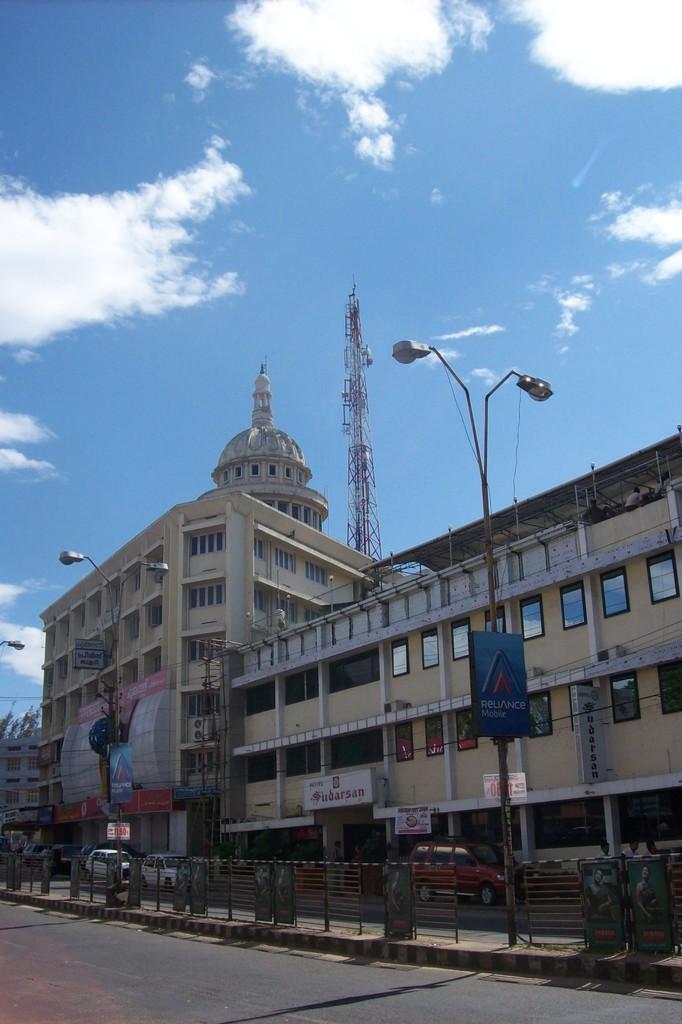Please provide a concise description of this image. In front of the image there is a road, beside the road there is a divider with metal rod partition, on the divider there are lamp posts with display boards on it, on the other side of the road there are vehicles on the road and there are a few people walking on the pavement, on the other side of the pavement there are buildings with banners and display boards, behind the buildings there is a tower, at the top of the image there are clouds in the sky. 